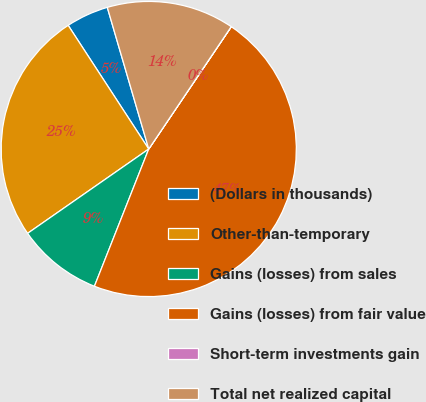Convert chart to OTSL. <chart><loc_0><loc_0><loc_500><loc_500><pie_chart><fcel>(Dollars in thousands)<fcel>Other-than-temporary<fcel>Gains (losses) from sales<fcel>Gains (losses) from fair value<fcel>Short-term investments gain<fcel>Total net realized capital<nl><fcel>4.66%<fcel>25.49%<fcel>9.32%<fcel>46.55%<fcel>0.01%<fcel>13.97%<nl></chart> 